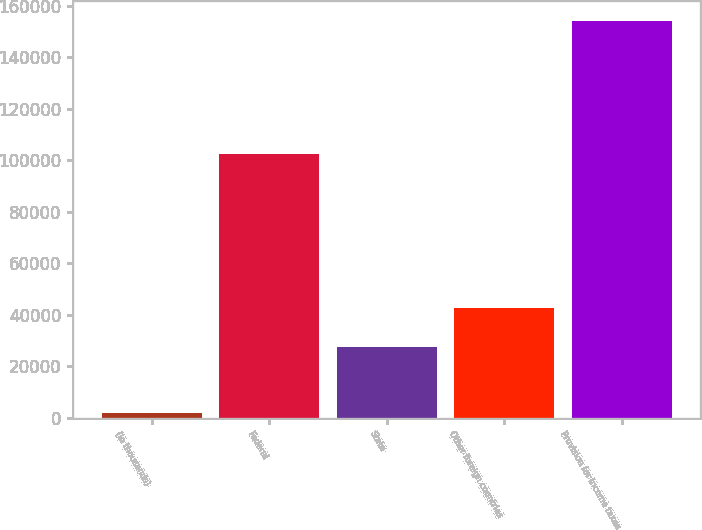Convert chart. <chart><loc_0><loc_0><loc_500><loc_500><bar_chart><fcel>(In thousands)<fcel>Federal<fcel>State<fcel>Other foreign countries<fcel>Provision for income taxes<nl><fcel>2015<fcel>102317<fcel>27500<fcel>42709.7<fcel>154112<nl></chart> 